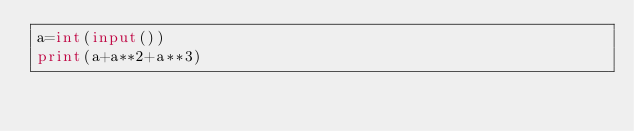<code> <loc_0><loc_0><loc_500><loc_500><_Python_>a=int(input())
print(a+a**2+a**3)</code> 